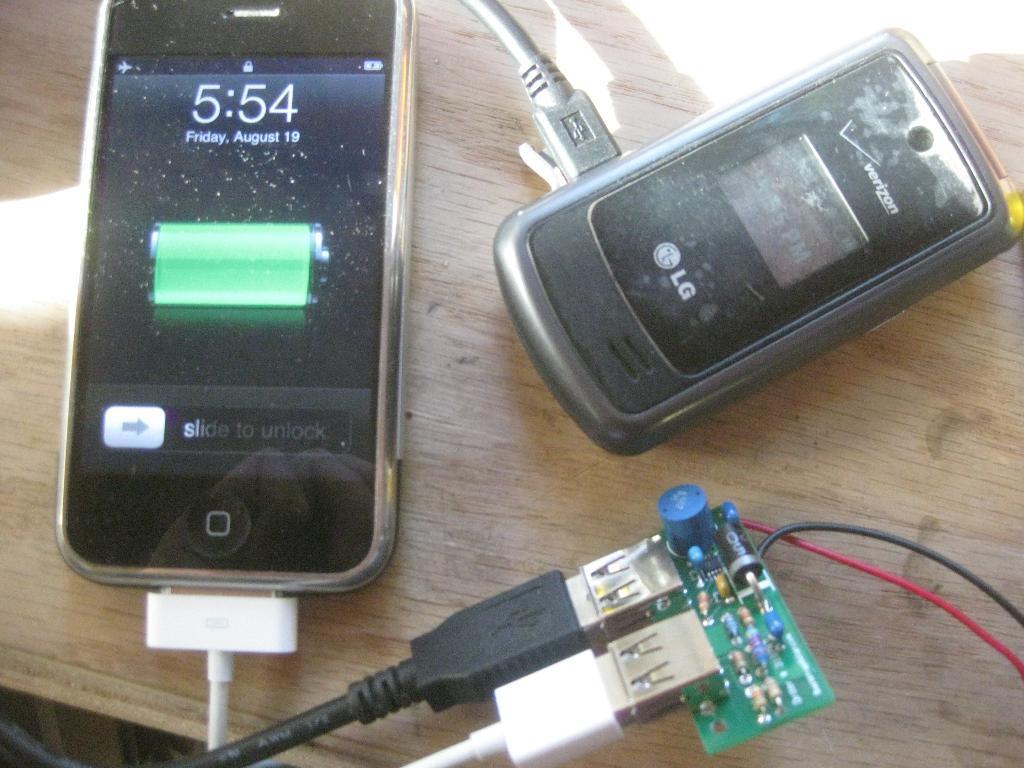Does this look like a bomb to you?
Provide a succinct answer. Unanswerable. 